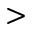<formula> <loc_0><loc_0><loc_500><loc_500>></formula> 